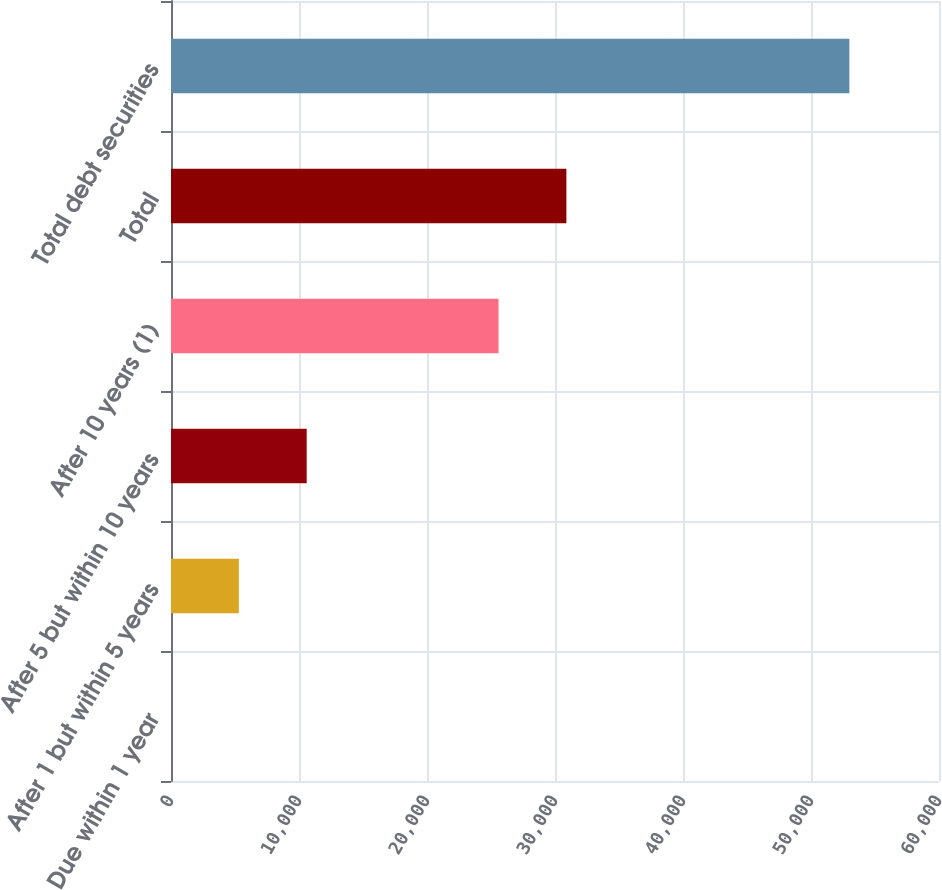<chart> <loc_0><loc_0><loc_500><loc_500><bar_chart><fcel>Due within 1 year<fcel>After 1 but within 5 years<fcel>After 5 but within 10 years<fcel>After 10 years (1)<fcel>Total<fcel>Total debt securities<nl><fcel>1<fcel>5300.7<fcel>10600.4<fcel>25589<fcel>30888.7<fcel>52998<nl></chart> 